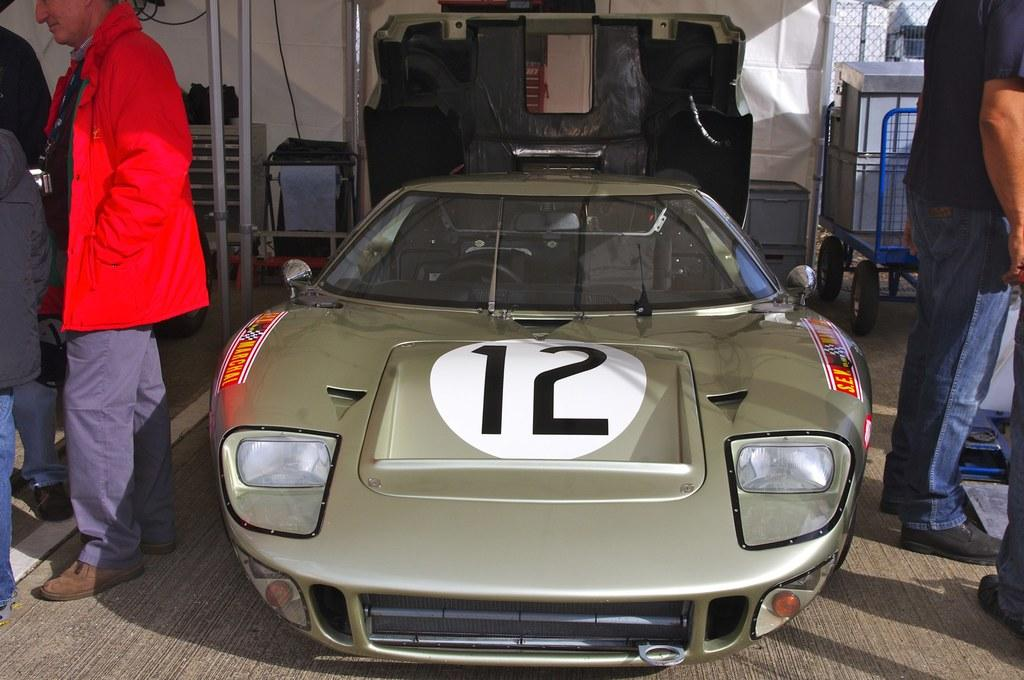What color is predominantly visible in the image? The image contains green color. Can you describe the positions of the men in the image? Men are standing on both sides of the image. What is the background of the image made of? The background of the image is a white color sheet. What type of objects are made of metal in the image? There are metal things present in the image. What type of notebook can be seen in the image? There is no notebook present in the image. What is the name of the downtown area visible in the image? There is no downtown area visible in the image. 